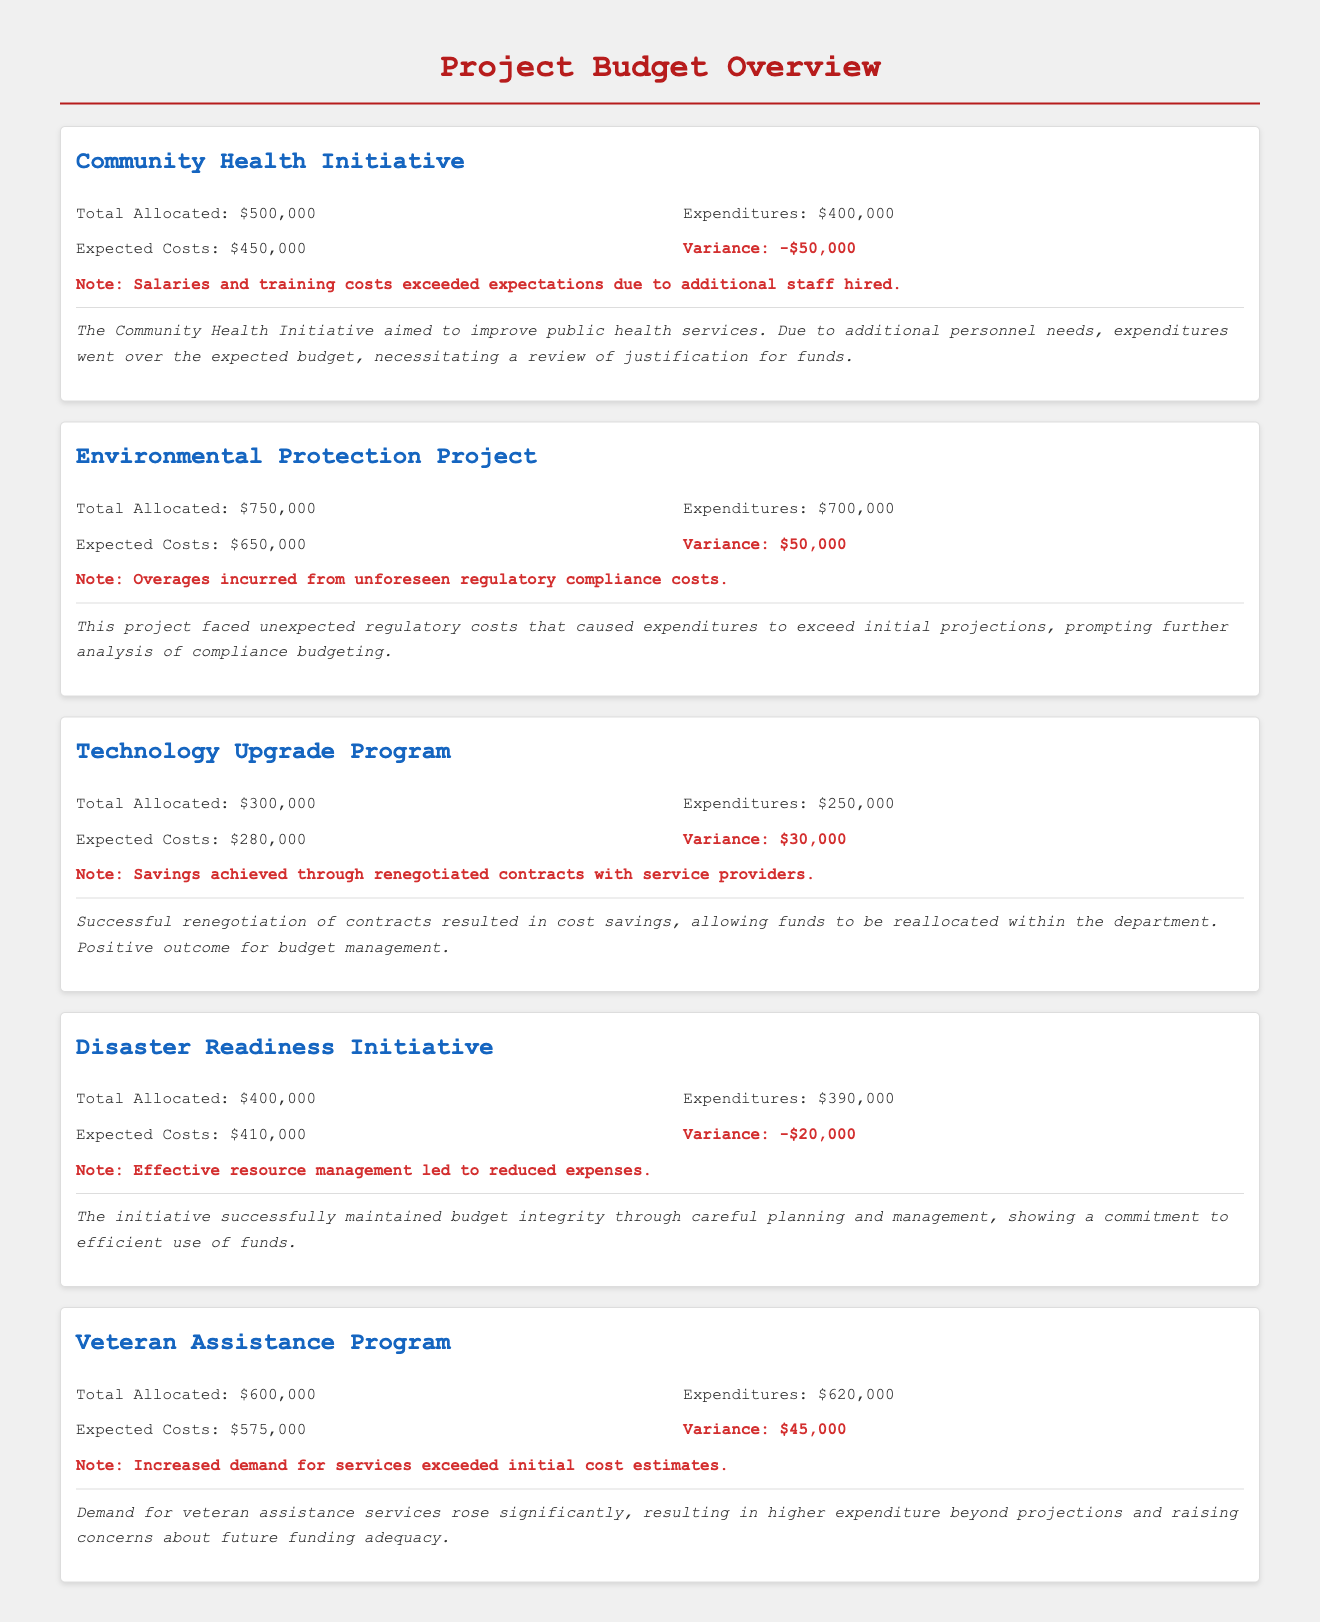What is the total allocated budget for the Community Health Initiative? The total allocated budget for the Community Health Initiative is specifically stated in the document.
Answer: $500,000 What is the variance for the Environmental Protection Project? The variance figure is provided under the project details, showing the difference between expenditures and expected costs.
Answer: $50,000 How much was spent on the Technology Upgrade Program? The expenditures for the Technology Upgrade Program are explicitly mentioned in the overview.
Answer: $250,000 What are the expected costs for the Disaster Readiness Initiative? The expected costs figure shows the anticipated financial requirements for the project, detailed in the document.
Answer: $410,000 What caused the expenditures to exceed the budget in the Veteran Assistance Program? The document provides a note explaining that the increase was due to higher demand for services, thus detailing the reasoning behind the costs.
Answer: Increased demand for services Which project achieved savings through renegotiated contracts? The name of the project achieving savings is outlined in its summary, indicating an effective cost management strategy utilized.
Answer: Technology Upgrade Program What was the total allocated budget for the Veteran Assistance Program? This number is stated in the budget details for the project within the document.
Answer: $600,000 What is the summary of the Community Health Initiative? A brief summary is provided in the document that encapsulates the project’s aim and the budget concerns it faced.
Answer: The Community Health Initiative aimed to improve public health services What financial strategy was highlighted in the document for the Disaster Readiness Initiative? The summary indicates that effective resource management was key to maintaining budget integrity in this initiative.
Answer: Effective resource management 